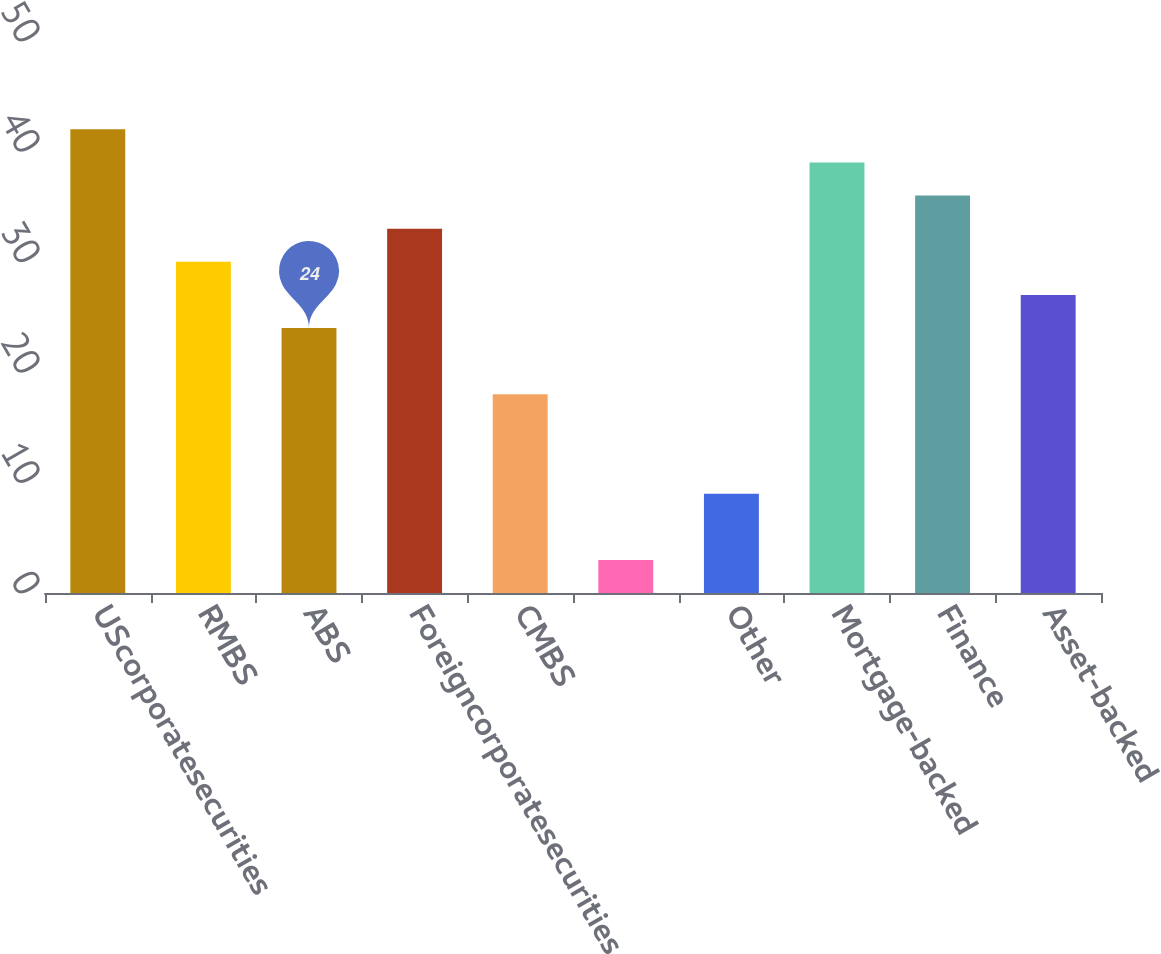Convert chart to OTSL. <chart><loc_0><loc_0><loc_500><loc_500><bar_chart><fcel>UScorporatesecurities<fcel>RMBS<fcel>ABS<fcel>Foreigncorporatesecurities<fcel>CMBS<fcel>Unnamed: 5<fcel>Other<fcel>Mortgage-backed<fcel>Finance<fcel>Asset-backed<nl><fcel>42<fcel>30<fcel>24<fcel>33<fcel>18<fcel>3<fcel>9<fcel>39<fcel>36<fcel>27<nl></chart> 